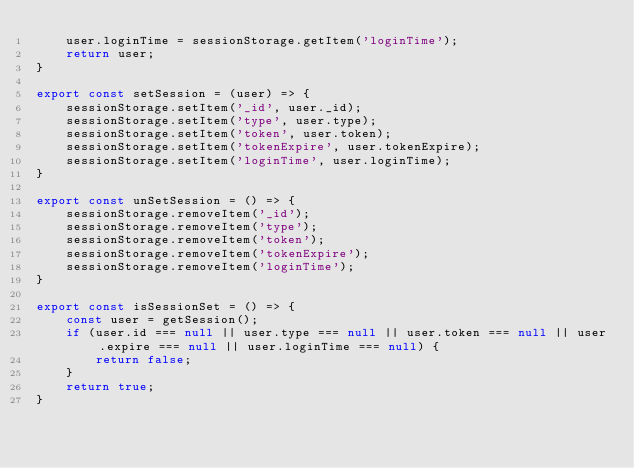Convert code to text. <code><loc_0><loc_0><loc_500><loc_500><_JavaScript_>    user.loginTime = sessionStorage.getItem('loginTime');
    return user;
}

export const setSession = (user) => {
    sessionStorage.setItem('_id', user._id);
    sessionStorage.setItem('type', user.type);
    sessionStorage.setItem('token', user.token);
    sessionStorage.setItem('tokenExpire', user.tokenExpire);
    sessionStorage.setItem('loginTime', user.loginTime);
}

export const unSetSession = () => {
    sessionStorage.removeItem('_id');
    sessionStorage.removeItem('type');
    sessionStorage.removeItem('token');
    sessionStorage.removeItem('tokenExpire');
    sessionStorage.removeItem('loginTime');
}

export const isSessionSet = () => {
    const user = getSession();
    if (user.id === null || user.type === null || user.token === null || user.expire === null || user.loginTime === null) {
        return false;
    }
    return true;
}

</code> 